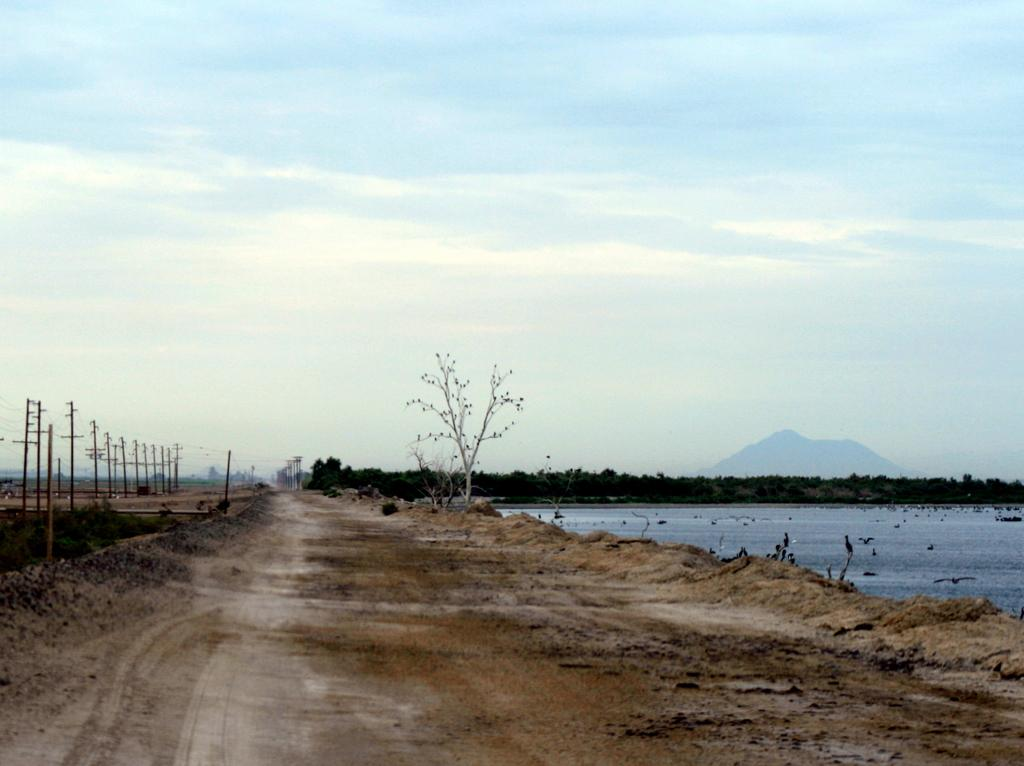What can be seen running through the image? There is a path in the image. What structures are located beside the path? There are utility poles beside the path. What type of vegetation is present on one side of the path? There are trees on one side of the path. What natural feature is on the other side of the path? There is a river on one side of the path. What is visible in the background of the image? The sky is visible in the background of the image. What type of fruit is being transported in a crate along the path in the image? There is no fruit or crate present in the image; it only features a path, utility poles, trees, a river, and the sky. 